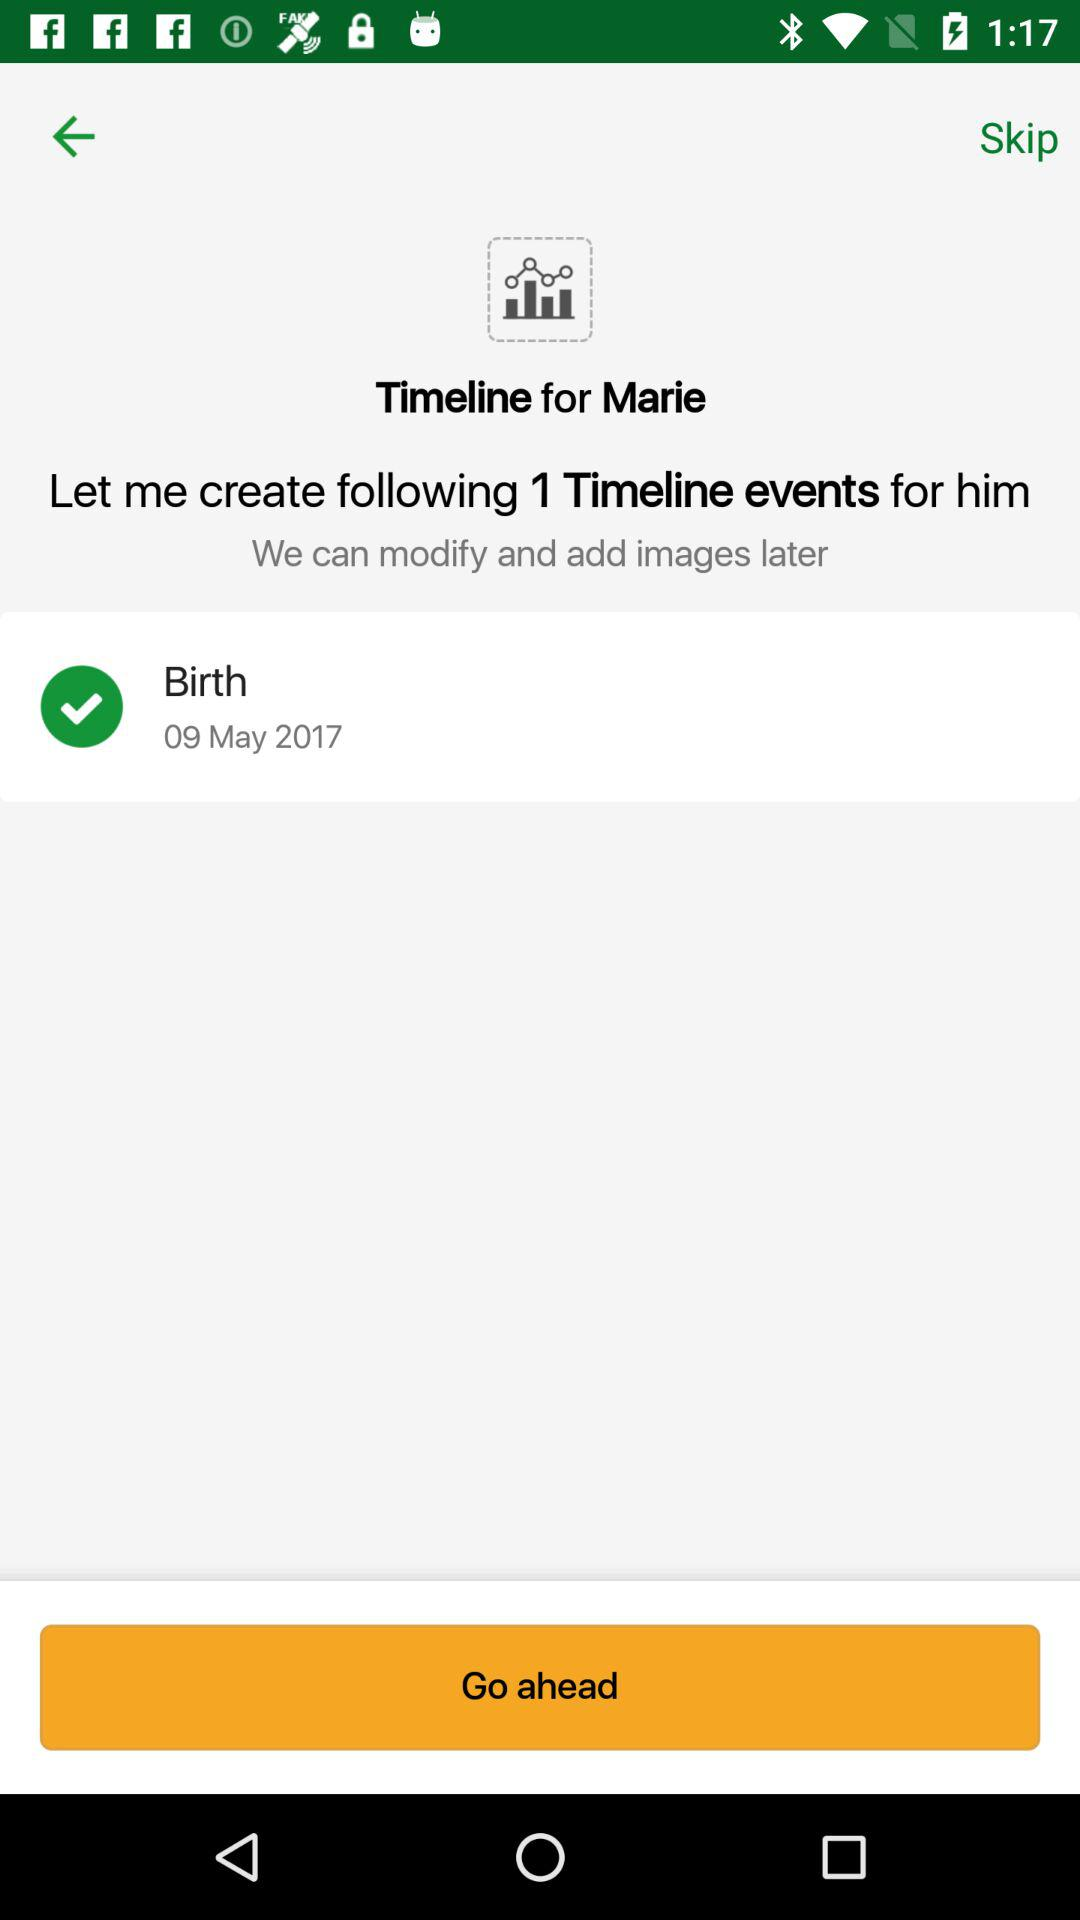How many events are there in this timeline?
Answer the question using a single word or phrase. 1 